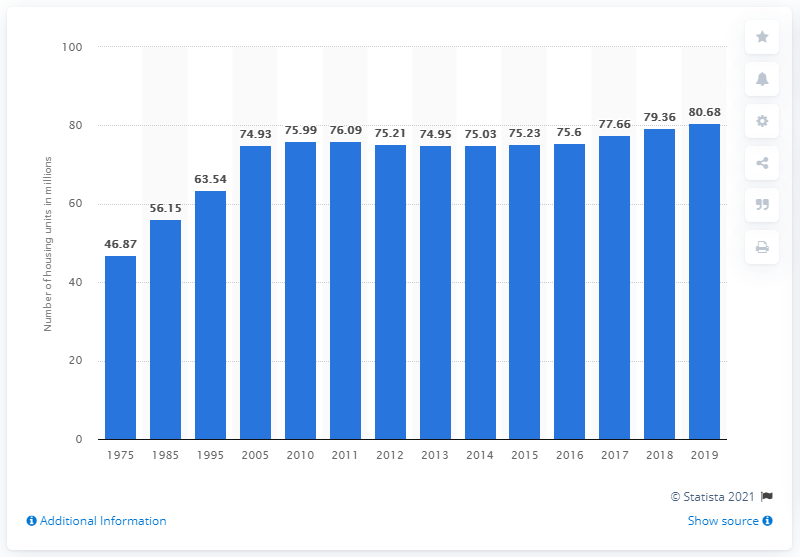Mention a couple of crucial points in this snapshot. In 2019, the number of owner-occupied housing units in the United States was 80.68 million. 